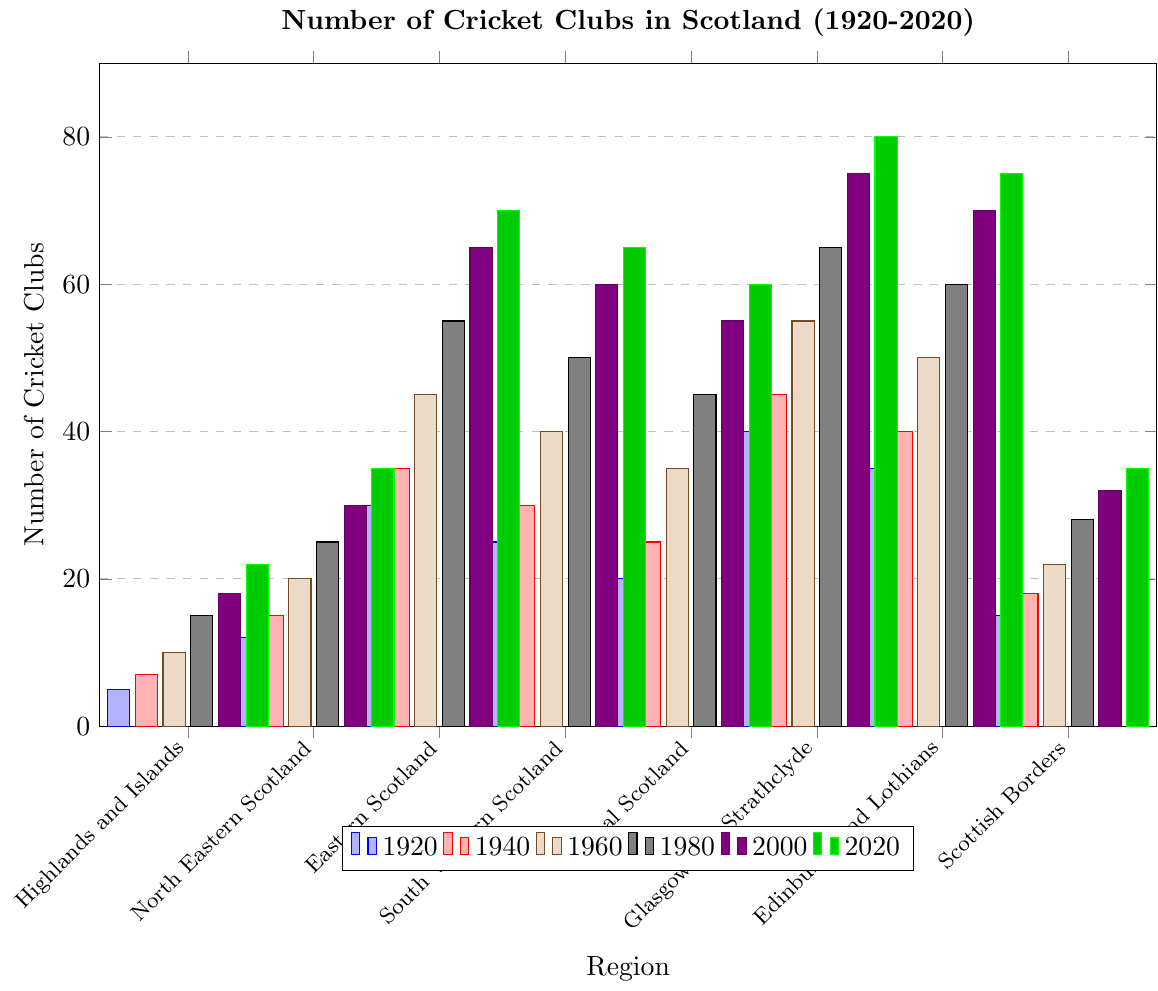Which region had the most cricket clubs in 1920? Identify the tallest bar among the regions in the year 1920.
Answer: Glasgow and Strathclyde Which region had the least increase in the number of cricket clubs from 1920 to 2020? Calculate the difference between 1920 and 2020 for each region, and identify the smallest value.
Answer: Highlands and Islands What was the total number of cricket clubs in Scotland in 1980? Sum the number of clubs for all regions in the year 1980. Calculation: 15+25+55+50+45+65+60+28
Answer: 343 Which two regions had the most similar number of cricket clubs in 2000? Compare the values for all regions in 2000 and identify the two closest values. Edinburgh and Lothians and Central Scotland both have 70 and 55, resulting in a difference of 15, which is the smallest difference.
Answer: North Eastern Scotland and Scottish Borders During which decade did the number of cricket clubs in Edinburgh and Lothians exceed those in Glasgow and Strathclyde? Inspect the bars for Edinburgh and Lothians and Glasgow and Strathclyde across the decades and identify when the former's bar becomes higher than the latter's.
Answer: None How many more cricket clubs were there in Eastern Scotland compared to Central Scotland in 2020? Subtract the number of clubs in Central Scotland from the number in Eastern Scotland for the year 2020. Calculation: 70 - 60
Answer: 10 Which decade saw the greatest growth in the number of cricket clubs in Central Scotland? Identify the decade with the largest increase by calculating the differences for each decade. Calculation: 1960-1940: 35-25=10, 1980-1960: 45-35=10, etc.
Answer: 1940-1960 and 1980-2000 Was there any region whose number of cricket clubs did not change from one decade to the next? If so, which region and decade? Check all regions for changes in each decade and identify if any value did not change.
Answer: None 